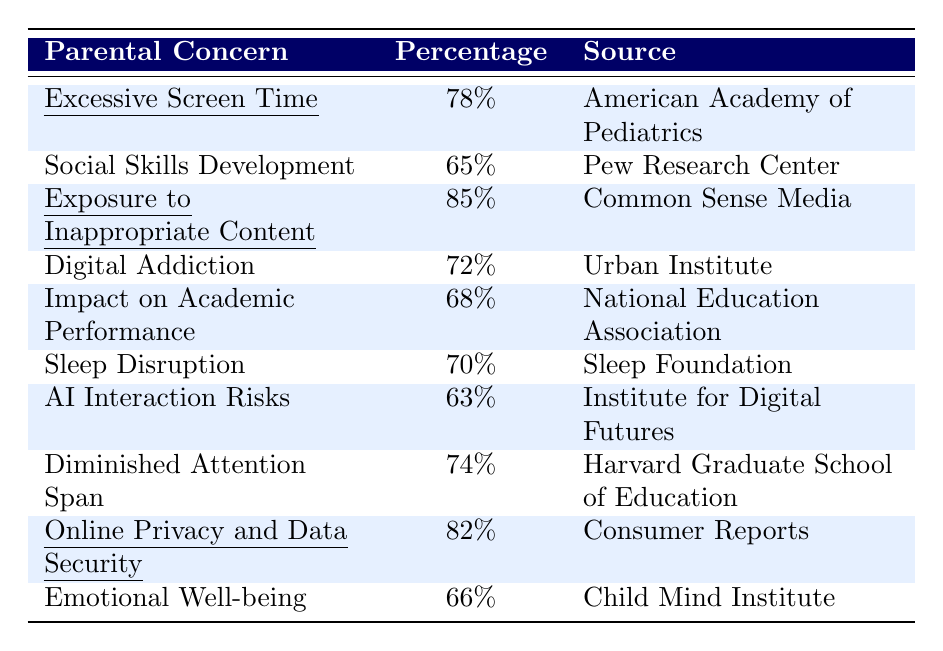What percentage of parents are concerned about excessive screen time? According to the table, the percentage of parents worried about excessive screen time is 78%.
Answer: 78% Which concern has the highest percentage among parents? By examining the percentages, the highest concern listed is exposure to inappropriate content, which is 85%.
Answer: 85% How many more parents are concerned about online privacy and data security compared to AI interaction risks? The percentage for online privacy and data security is 82%, and for AI interaction risks, it is 63%. The difference is 82% - 63% = 19%.
Answer: 19% What is the average percentage of parental concerns listed in the table? To find the average, add all the percentages: 78 + 65 + 85 + 72 + 68 + 70 + 63 + 74 + 82 + 66 =  788. There are 10 concerns, so the average is 788/10 = 78.8%.
Answer: 78.8% Is the concern regarding emotional well-being greater than that of digital addiction? Emotional well-being has a percentage of 66%, while digital addiction is at 72%. Since 66% is less than 72%, the statement is false.
Answer: No Which concerns have percentages above 70%? The concerns with percentages above 70% are excessive screen time (78%), exposure to inappropriate content (85%), digital addiction (72%), sleep disruption (70%), online privacy and data security (82%), and diminished attention span (74%).
Answer: 6 concerns What percentage of parents express concerns about both digital addiction and sleep disruption? The percentage for digital addiction is 72%, and for sleep disruption, it is 70%. Both percentages are noted, indicating that parents have concerns about both issues.
Answer: 72% and 70% Which two concerns have the smallest percentage? By comparing the percentages, the concerns with the smallest percentages are social skills development (65%) and emotional well-being (66%).
Answer: 65% and 66% What is the total percentage of parents concerned about social skills development and emotional well-being? The percentage for social skills development is 65%, and for emotional well-being, it is 66%. Summing these gives 65% + 66% = 131%.
Answer: 131% Is there a greater concern about exposure to inappropriate content or diminished attention span? Exposure to inappropriate content is at 85%, while diminished attention span is 74%. Since 85% is greater than 74%, the concern about exposure to inappropriate content is higher.
Answer: Yes 